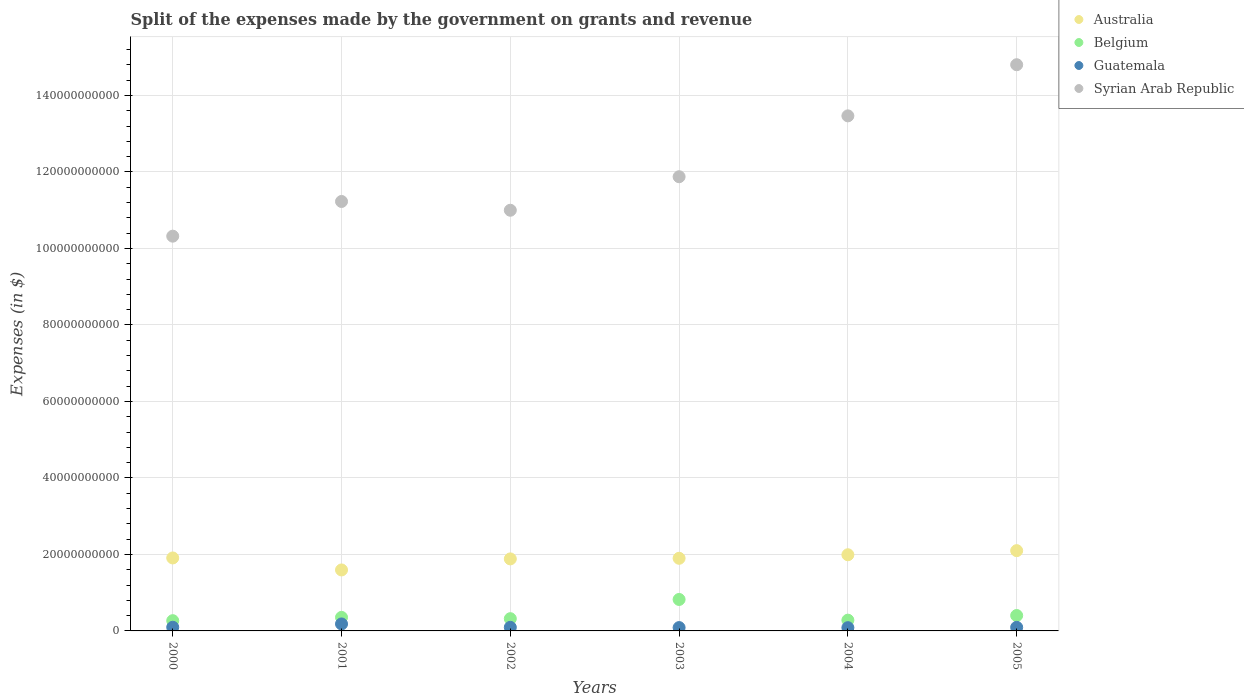Is the number of dotlines equal to the number of legend labels?
Ensure brevity in your answer.  Yes. What is the expenses made by the government on grants and revenue in Syrian Arab Republic in 2002?
Offer a terse response. 1.10e+11. Across all years, what is the maximum expenses made by the government on grants and revenue in Belgium?
Offer a very short reply. 8.23e+09. Across all years, what is the minimum expenses made by the government on grants and revenue in Guatemala?
Offer a very short reply. 8.48e+08. In which year was the expenses made by the government on grants and revenue in Australia maximum?
Your answer should be very brief. 2005. What is the total expenses made by the government on grants and revenue in Syrian Arab Republic in the graph?
Your answer should be compact. 7.27e+11. What is the difference between the expenses made by the government on grants and revenue in Australia in 2000 and that in 2001?
Give a very brief answer. 3.14e+09. What is the difference between the expenses made by the government on grants and revenue in Guatemala in 2004 and the expenses made by the government on grants and revenue in Syrian Arab Republic in 2000?
Your answer should be compact. -1.02e+11. What is the average expenses made by the government on grants and revenue in Belgium per year?
Provide a succinct answer. 4.08e+09. In the year 2001, what is the difference between the expenses made by the government on grants and revenue in Australia and expenses made by the government on grants and revenue in Syrian Arab Republic?
Give a very brief answer. -9.63e+1. What is the ratio of the expenses made by the government on grants and revenue in Syrian Arab Republic in 2000 to that in 2003?
Offer a very short reply. 0.87. Is the expenses made by the government on grants and revenue in Australia in 2003 less than that in 2005?
Offer a terse response. Yes. Is the difference between the expenses made by the government on grants and revenue in Australia in 2000 and 2005 greater than the difference between the expenses made by the government on grants and revenue in Syrian Arab Republic in 2000 and 2005?
Offer a terse response. Yes. What is the difference between the highest and the second highest expenses made by the government on grants and revenue in Syrian Arab Republic?
Make the answer very short. 1.34e+1. What is the difference between the highest and the lowest expenses made by the government on grants and revenue in Syrian Arab Republic?
Offer a very short reply. 4.48e+1. Is the sum of the expenses made by the government on grants and revenue in Belgium in 2002 and 2005 greater than the maximum expenses made by the government on grants and revenue in Syrian Arab Republic across all years?
Your answer should be very brief. No. Are the values on the major ticks of Y-axis written in scientific E-notation?
Offer a very short reply. No. Does the graph contain grids?
Your answer should be very brief. Yes. Where does the legend appear in the graph?
Provide a succinct answer. Top right. How many legend labels are there?
Give a very brief answer. 4. What is the title of the graph?
Your response must be concise. Split of the expenses made by the government on grants and revenue. Does "Liberia" appear as one of the legend labels in the graph?
Offer a very short reply. No. What is the label or title of the Y-axis?
Your answer should be compact. Expenses (in $). What is the Expenses (in $) in Australia in 2000?
Your answer should be compact. 1.91e+1. What is the Expenses (in $) in Belgium in 2000?
Provide a short and direct response. 2.68e+09. What is the Expenses (in $) of Guatemala in 2000?
Provide a short and direct response. 9.60e+08. What is the Expenses (in $) in Syrian Arab Republic in 2000?
Your answer should be compact. 1.03e+11. What is the Expenses (in $) in Australia in 2001?
Provide a short and direct response. 1.59e+1. What is the Expenses (in $) in Belgium in 2001?
Offer a terse response. 3.54e+09. What is the Expenses (in $) in Guatemala in 2001?
Provide a short and direct response. 1.82e+09. What is the Expenses (in $) in Syrian Arab Republic in 2001?
Your answer should be very brief. 1.12e+11. What is the Expenses (in $) of Australia in 2002?
Your answer should be very brief. 1.88e+1. What is the Expenses (in $) in Belgium in 2002?
Your answer should be very brief. 3.20e+09. What is the Expenses (in $) of Guatemala in 2002?
Give a very brief answer. 9.40e+08. What is the Expenses (in $) of Syrian Arab Republic in 2002?
Your response must be concise. 1.10e+11. What is the Expenses (in $) in Australia in 2003?
Offer a very short reply. 1.90e+1. What is the Expenses (in $) of Belgium in 2003?
Offer a very short reply. 8.23e+09. What is the Expenses (in $) of Guatemala in 2003?
Provide a short and direct response. 8.72e+08. What is the Expenses (in $) in Syrian Arab Republic in 2003?
Your answer should be very brief. 1.19e+11. What is the Expenses (in $) in Australia in 2004?
Ensure brevity in your answer.  1.99e+1. What is the Expenses (in $) of Belgium in 2004?
Make the answer very short. 2.81e+09. What is the Expenses (in $) in Guatemala in 2004?
Ensure brevity in your answer.  8.48e+08. What is the Expenses (in $) of Syrian Arab Republic in 2004?
Ensure brevity in your answer.  1.35e+11. What is the Expenses (in $) in Australia in 2005?
Your answer should be compact. 2.10e+1. What is the Expenses (in $) in Belgium in 2005?
Your response must be concise. 4.03e+09. What is the Expenses (in $) in Guatemala in 2005?
Your response must be concise. 9.38e+08. What is the Expenses (in $) of Syrian Arab Republic in 2005?
Ensure brevity in your answer.  1.48e+11. Across all years, what is the maximum Expenses (in $) of Australia?
Ensure brevity in your answer.  2.10e+1. Across all years, what is the maximum Expenses (in $) in Belgium?
Keep it short and to the point. 8.23e+09. Across all years, what is the maximum Expenses (in $) of Guatemala?
Keep it short and to the point. 1.82e+09. Across all years, what is the maximum Expenses (in $) of Syrian Arab Republic?
Offer a very short reply. 1.48e+11. Across all years, what is the minimum Expenses (in $) in Australia?
Your response must be concise. 1.59e+1. Across all years, what is the minimum Expenses (in $) of Belgium?
Provide a succinct answer. 2.68e+09. Across all years, what is the minimum Expenses (in $) in Guatemala?
Offer a very short reply. 8.48e+08. Across all years, what is the minimum Expenses (in $) of Syrian Arab Republic?
Your answer should be very brief. 1.03e+11. What is the total Expenses (in $) in Australia in the graph?
Ensure brevity in your answer.  1.14e+11. What is the total Expenses (in $) in Belgium in the graph?
Provide a succinct answer. 2.45e+1. What is the total Expenses (in $) in Guatemala in the graph?
Keep it short and to the point. 6.38e+09. What is the total Expenses (in $) in Syrian Arab Republic in the graph?
Make the answer very short. 7.27e+11. What is the difference between the Expenses (in $) of Australia in 2000 and that in 2001?
Your answer should be very brief. 3.14e+09. What is the difference between the Expenses (in $) in Belgium in 2000 and that in 2001?
Ensure brevity in your answer.  -8.60e+08. What is the difference between the Expenses (in $) of Guatemala in 2000 and that in 2001?
Offer a very short reply. -8.65e+08. What is the difference between the Expenses (in $) in Syrian Arab Republic in 2000 and that in 2001?
Keep it short and to the point. -9.07e+09. What is the difference between the Expenses (in $) of Australia in 2000 and that in 2002?
Your response must be concise. 2.47e+08. What is the difference between the Expenses (in $) of Belgium in 2000 and that in 2002?
Provide a short and direct response. -5.22e+08. What is the difference between the Expenses (in $) of Guatemala in 2000 and that in 2002?
Offer a terse response. 1.94e+07. What is the difference between the Expenses (in $) of Syrian Arab Republic in 2000 and that in 2002?
Provide a succinct answer. -6.78e+09. What is the difference between the Expenses (in $) of Australia in 2000 and that in 2003?
Provide a short and direct response. 8.90e+07. What is the difference between the Expenses (in $) in Belgium in 2000 and that in 2003?
Provide a short and direct response. -5.55e+09. What is the difference between the Expenses (in $) of Guatemala in 2000 and that in 2003?
Offer a terse response. 8.76e+07. What is the difference between the Expenses (in $) of Syrian Arab Republic in 2000 and that in 2003?
Your answer should be very brief. -1.55e+1. What is the difference between the Expenses (in $) of Australia in 2000 and that in 2004?
Provide a succinct answer. -8.35e+08. What is the difference between the Expenses (in $) in Belgium in 2000 and that in 2004?
Offer a terse response. -1.35e+08. What is the difference between the Expenses (in $) of Guatemala in 2000 and that in 2004?
Offer a terse response. 1.11e+08. What is the difference between the Expenses (in $) in Syrian Arab Republic in 2000 and that in 2004?
Your response must be concise. -3.15e+1. What is the difference between the Expenses (in $) of Australia in 2000 and that in 2005?
Keep it short and to the point. -1.91e+09. What is the difference between the Expenses (in $) in Belgium in 2000 and that in 2005?
Your answer should be very brief. -1.35e+09. What is the difference between the Expenses (in $) in Guatemala in 2000 and that in 2005?
Your answer should be compact. 2.17e+07. What is the difference between the Expenses (in $) in Syrian Arab Republic in 2000 and that in 2005?
Give a very brief answer. -4.48e+1. What is the difference between the Expenses (in $) in Australia in 2001 and that in 2002?
Offer a very short reply. -2.89e+09. What is the difference between the Expenses (in $) of Belgium in 2001 and that in 2002?
Your response must be concise. 3.37e+08. What is the difference between the Expenses (in $) of Guatemala in 2001 and that in 2002?
Provide a short and direct response. 8.85e+08. What is the difference between the Expenses (in $) in Syrian Arab Republic in 2001 and that in 2002?
Your answer should be very brief. 2.29e+09. What is the difference between the Expenses (in $) of Australia in 2001 and that in 2003?
Your answer should be very brief. -3.05e+09. What is the difference between the Expenses (in $) in Belgium in 2001 and that in 2003?
Offer a terse response. -4.69e+09. What is the difference between the Expenses (in $) in Guatemala in 2001 and that in 2003?
Provide a succinct answer. 9.53e+08. What is the difference between the Expenses (in $) in Syrian Arab Republic in 2001 and that in 2003?
Provide a short and direct response. -6.47e+09. What is the difference between the Expenses (in $) of Australia in 2001 and that in 2004?
Make the answer very short. -3.97e+09. What is the difference between the Expenses (in $) of Belgium in 2001 and that in 2004?
Your answer should be compact. 7.25e+08. What is the difference between the Expenses (in $) in Guatemala in 2001 and that in 2004?
Keep it short and to the point. 9.76e+08. What is the difference between the Expenses (in $) in Syrian Arab Republic in 2001 and that in 2004?
Provide a short and direct response. -2.24e+1. What is the difference between the Expenses (in $) of Australia in 2001 and that in 2005?
Offer a very short reply. -5.04e+09. What is the difference between the Expenses (in $) in Belgium in 2001 and that in 2005?
Offer a terse response. -4.90e+08. What is the difference between the Expenses (in $) of Guatemala in 2001 and that in 2005?
Offer a very short reply. 8.87e+08. What is the difference between the Expenses (in $) in Syrian Arab Republic in 2001 and that in 2005?
Ensure brevity in your answer.  -3.58e+1. What is the difference between the Expenses (in $) in Australia in 2002 and that in 2003?
Give a very brief answer. -1.58e+08. What is the difference between the Expenses (in $) of Belgium in 2002 and that in 2003?
Make the answer very short. -5.02e+09. What is the difference between the Expenses (in $) of Guatemala in 2002 and that in 2003?
Your answer should be very brief. 6.82e+07. What is the difference between the Expenses (in $) in Syrian Arab Republic in 2002 and that in 2003?
Your response must be concise. -8.76e+09. What is the difference between the Expenses (in $) in Australia in 2002 and that in 2004?
Provide a succinct answer. -1.08e+09. What is the difference between the Expenses (in $) in Belgium in 2002 and that in 2004?
Offer a very short reply. 3.88e+08. What is the difference between the Expenses (in $) of Guatemala in 2002 and that in 2004?
Your answer should be very brief. 9.19e+07. What is the difference between the Expenses (in $) in Syrian Arab Republic in 2002 and that in 2004?
Keep it short and to the point. -2.47e+1. What is the difference between the Expenses (in $) in Australia in 2002 and that in 2005?
Your response must be concise. -2.16e+09. What is the difference between the Expenses (in $) in Belgium in 2002 and that in 2005?
Offer a terse response. -8.27e+08. What is the difference between the Expenses (in $) in Guatemala in 2002 and that in 2005?
Offer a very short reply. 2.33e+06. What is the difference between the Expenses (in $) of Syrian Arab Republic in 2002 and that in 2005?
Provide a succinct answer. -3.80e+1. What is the difference between the Expenses (in $) of Australia in 2003 and that in 2004?
Offer a very short reply. -9.24e+08. What is the difference between the Expenses (in $) of Belgium in 2003 and that in 2004?
Make the answer very short. 5.41e+09. What is the difference between the Expenses (in $) in Guatemala in 2003 and that in 2004?
Provide a short and direct response. 2.36e+07. What is the difference between the Expenses (in $) of Syrian Arab Republic in 2003 and that in 2004?
Ensure brevity in your answer.  -1.59e+1. What is the difference between the Expenses (in $) in Australia in 2003 and that in 2005?
Ensure brevity in your answer.  -2.00e+09. What is the difference between the Expenses (in $) of Belgium in 2003 and that in 2005?
Offer a very short reply. 4.20e+09. What is the difference between the Expenses (in $) in Guatemala in 2003 and that in 2005?
Your response must be concise. -6.59e+07. What is the difference between the Expenses (in $) in Syrian Arab Republic in 2003 and that in 2005?
Provide a succinct answer. -2.93e+1. What is the difference between the Expenses (in $) of Australia in 2004 and that in 2005?
Provide a short and direct response. -1.07e+09. What is the difference between the Expenses (in $) in Belgium in 2004 and that in 2005?
Keep it short and to the point. -1.21e+09. What is the difference between the Expenses (in $) of Guatemala in 2004 and that in 2005?
Your answer should be very brief. -8.95e+07. What is the difference between the Expenses (in $) in Syrian Arab Republic in 2004 and that in 2005?
Your response must be concise. -1.34e+1. What is the difference between the Expenses (in $) in Australia in 2000 and the Expenses (in $) in Belgium in 2001?
Offer a very short reply. 1.55e+1. What is the difference between the Expenses (in $) of Australia in 2000 and the Expenses (in $) of Guatemala in 2001?
Provide a short and direct response. 1.73e+1. What is the difference between the Expenses (in $) of Australia in 2000 and the Expenses (in $) of Syrian Arab Republic in 2001?
Offer a very short reply. -9.32e+1. What is the difference between the Expenses (in $) of Belgium in 2000 and the Expenses (in $) of Guatemala in 2001?
Provide a succinct answer. 8.53e+08. What is the difference between the Expenses (in $) in Belgium in 2000 and the Expenses (in $) in Syrian Arab Republic in 2001?
Offer a terse response. -1.10e+11. What is the difference between the Expenses (in $) of Guatemala in 2000 and the Expenses (in $) of Syrian Arab Republic in 2001?
Ensure brevity in your answer.  -1.11e+11. What is the difference between the Expenses (in $) in Australia in 2000 and the Expenses (in $) in Belgium in 2002?
Your answer should be compact. 1.59e+1. What is the difference between the Expenses (in $) in Australia in 2000 and the Expenses (in $) in Guatemala in 2002?
Keep it short and to the point. 1.81e+1. What is the difference between the Expenses (in $) in Australia in 2000 and the Expenses (in $) in Syrian Arab Republic in 2002?
Your response must be concise. -9.09e+1. What is the difference between the Expenses (in $) in Belgium in 2000 and the Expenses (in $) in Guatemala in 2002?
Offer a very short reply. 1.74e+09. What is the difference between the Expenses (in $) in Belgium in 2000 and the Expenses (in $) in Syrian Arab Republic in 2002?
Provide a succinct answer. -1.07e+11. What is the difference between the Expenses (in $) of Guatemala in 2000 and the Expenses (in $) of Syrian Arab Republic in 2002?
Offer a very short reply. -1.09e+11. What is the difference between the Expenses (in $) of Australia in 2000 and the Expenses (in $) of Belgium in 2003?
Your answer should be compact. 1.09e+1. What is the difference between the Expenses (in $) of Australia in 2000 and the Expenses (in $) of Guatemala in 2003?
Your answer should be compact. 1.82e+1. What is the difference between the Expenses (in $) in Australia in 2000 and the Expenses (in $) in Syrian Arab Republic in 2003?
Your answer should be compact. -9.97e+1. What is the difference between the Expenses (in $) of Belgium in 2000 and the Expenses (in $) of Guatemala in 2003?
Provide a short and direct response. 1.81e+09. What is the difference between the Expenses (in $) in Belgium in 2000 and the Expenses (in $) in Syrian Arab Republic in 2003?
Give a very brief answer. -1.16e+11. What is the difference between the Expenses (in $) in Guatemala in 2000 and the Expenses (in $) in Syrian Arab Republic in 2003?
Offer a very short reply. -1.18e+11. What is the difference between the Expenses (in $) of Australia in 2000 and the Expenses (in $) of Belgium in 2004?
Your response must be concise. 1.63e+1. What is the difference between the Expenses (in $) in Australia in 2000 and the Expenses (in $) in Guatemala in 2004?
Offer a terse response. 1.82e+1. What is the difference between the Expenses (in $) of Australia in 2000 and the Expenses (in $) of Syrian Arab Republic in 2004?
Keep it short and to the point. -1.16e+11. What is the difference between the Expenses (in $) of Belgium in 2000 and the Expenses (in $) of Guatemala in 2004?
Offer a terse response. 1.83e+09. What is the difference between the Expenses (in $) in Belgium in 2000 and the Expenses (in $) in Syrian Arab Republic in 2004?
Provide a succinct answer. -1.32e+11. What is the difference between the Expenses (in $) of Guatemala in 2000 and the Expenses (in $) of Syrian Arab Republic in 2004?
Your answer should be very brief. -1.34e+11. What is the difference between the Expenses (in $) of Australia in 2000 and the Expenses (in $) of Belgium in 2005?
Ensure brevity in your answer.  1.51e+1. What is the difference between the Expenses (in $) in Australia in 2000 and the Expenses (in $) in Guatemala in 2005?
Provide a short and direct response. 1.81e+1. What is the difference between the Expenses (in $) of Australia in 2000 and the Expenses (in $) of Syrian Arab Republic in 2005?
Keep it short and to the point. -1.29e+11. What is the difference between the Expenses (in $) in Belgium in 2000 and the Expenses (in $) in Guatemala in 2005?
Ensure brevity in your answer.  1.74e+09. What is the difference between the Expenses (in $) in Belgium in 2000 and the Expenses (in $) in Syrian Arab Republic in 2005?
Offer a very short reply. -1.45e+11. What is the difference between the Expenses (in $) in Guatemala in 2000 and the Expenses (in $) in Syrian Arab Republic in 2005?
Keep it short and to the point. -1.47e+11. What is the difference between the Expenses (in $) in Australia in 2001 and the Expenses (in $) in Belgium in 2002?
Make the answer very short. 1.27e+1. What is the difference between the Expenses (in $) in Australia in 2001 and the Expenses (in $) in Guatemala in 2002?
Your answer should be compact. 1.50e+1. What is the difference between the Expenses (in $) in Australia in 2001 and the Expenses (in $) in Syrian Arab Republic in 2002?
Provide a succinct answer. -9.40e+1. What is the difference between the Expenses (in $) of Belgium in 2001 and the Expenses (in $) of Guatemala in 2002?
Provide a short and direct response. 2.60e+09. What is the difference between the Expenses (in $) in Belgium in 2001 and the Expenses (in $) in Syrian Arab Republic in 2002?
Ensure brevity in your answer.  -1.06e+11. What is the difference between the Expenses (in $) of Guatemala in 2001 and the Expenses (in $) of Syrian Arab Republic in 2002?
Your response must be concise. -1.08e+11. What is the difference between the Expenses (in $) in Australia in 2001 and the Expenses (in $) in Belgium in 2003?
Offer a terse response. 7.72e+09. What is the difference between the Expenses (in $) of Australia in 2001 and the Expenses (in $) of Guatemala in 2003?
Ensure brevity in your answer.  1.51e+1. What is the difference between the Expenses (in $) of Australia in 2001 and the Expenses (in $) of Syrian Arab Republic in 2003?
Offer a terse response. -1.03e+11. What is the difference between the Expenses (in $) of Belgium in 2001 and the Expenses (in $) of Guatemala in 2003?
Make the answer very short. 2.67e+09. What is the difference between the Expenses (in $) of Belgium in 2001 and the Expenses (in $) of Syrian Arab Republic in 2003?
Your answer should be very brief. -1.15e+11. What is the difference between the Expenses (in $) in Guatemala in 2001 and the Expenses (in $) in Syrian Arab Republic in 2003?
Offer a terse response. -1.17e+11. What is the difference between the Expenses (in $) of Australia in 2001 and the Expenses (in $) of Belgium in 2004?
Your response must be concise. 1.31e+1. What is the difference between the Expenses (in $) of Australia in 2001 and the Expenses (in $) of Guatemala in 2004?
Make the answer very short. 1.51e+1. What is the difference between the Expenses (in $) of Australia in 2001 and the Expenses (in $) of Syrian Arab Republic in 2004?
Provide a succinct answer. -1.19e+11. What is the difference between the Expenses (in $) of Belgium in 2001 and the Expenses (in $) of Guatemala in 2004?
Provide a succinct answer. 2.69e+09. What is the difference between the Expenses (in $) of Belgium in 2001 and the Expenses (in $) of Syrian Arab Republic in 2004?
Provide a short and direct response. -1.31e+11. What is the difference between the Expenses (in $) of Guatemala in 2001 and the Expenses (in $) of Syrian Arab Republic in 2004?
Provide a succinct answer. -1.33e+11. What is the difference between the Expenses (in $) in Australia in 2001 and the Expenses (in $) in Belgium in 2005?
Provide a short and direct response. 1.19e+1. What is the difference between the Expenses (in $) of Australia in 2001 and the Expenses (in $) of Guatemala in 2005?
Your answer should be very brief. 1.50e+1. What is the difference between the Expenses (in $) in Australia in 2001 and the Expenses (in $) in Syrian Arab Republic in 2005?
Your answer should be compact. -1.32e+11. What is the difference between the Expenses (in $) of Belgium in 2001 and the Expenses (in $) of Guatemala in 2005?
Make the answer very short. 2.60e+09. What is the difference between the Expenses (in $) of Belgium in 2001 and the Expenses (in $) of Syrian Arab Republic in 2005?
Offer a very short reply. -1.44e+11. What is the difference between the Expenses (in $) of Guatemala in 2001 and the Expenses (in $) of Syrian Arab Republic in 2005?
Offer a terse response. -1.46e+11. What is the difference between the Expenses (in $) in Australia in 2002 and the Expenses (in $) in Belgium in 2003?
Offer a very short reply. 1.06e+1. What is the difference between the Expenses (in $) of Australia in 2002 and the Expenses (in $) of Guatemala in 2003?
Provide a succinct answer. 1.80e+1. What is the difference between the Expenses (in $) in Australia in 2002 and the Expenses (in $) in Syrian Arab Republic in 2003?
Your answer should be very brief. -9.99e+1. What is the difference between the Expenses (in $) in Belgium in 2002 and the Expenses (in $) in Guatemala in 2003?
Give a very brief answer. 2.33e+09. What is the difference between the Expenses (in $) of Belgium in 2002 and the Expenses (in $) of Syrian Arab Republic in 2003?
Give a very brief answer. -1.16e+11. What is the difference between the Expenses (in $) of Guatemala in 2002 and the Expenses (in $) of Syrian Arab Republic in 2003?
Make the answer very short. -1.18e+11. What is the difference between the Expenses (in $) in Australia in 2002 and the Expenses (in $) in Belgium in 2004?
Keep it short and to the point. 1.60e+1. What is the difference between the Expenses (in $) of Australia in 2002 and the Expenses (in $) of Guatemala in 2004?
Your response must be concise. 1.80e+1. What is the difference between the Expenses (in $) in Australia in 2002 and the Expenses (in $) in Syrian Arab Republic in 2004?
Your response must be concise. -1.16e+11. What is the difference between the Expenses (in $) in Belgium in 2002 and the Expenses (in $) in Guatemala in 2004?
Offer a very short reply. 2.35e+09. What is the difference between the Expenses (in $) in Belgium in 2002 and the Expenses (in $) in Syrian Arab Republic in 2004?
Give a very brief answer. -1.31e+11. What is the difference between the Expenses (in $) of Guatemala in 2002 and the Expenses (in $) of Syrian Arab Republic in 2004?
Make the answer very short. -1.34e+11. What is the difference between the Expenses (in $) of Australia in 2002 and the Expenses (in $) of Belgium in 2005?
Offer a terse response. 1.48e+1. What is the difference between the Expenses (in $) in Australia in 2002 and the Expenses (in $) in Guatemala in 2005?
Make the answer very short. 1.79e+1. What is the difference between the Expenses (in $) in Australia in 2002 and the Expenses (in $) in Syrian Arab Republic in 2005?
Offer a very short reply. -1.29e+11. What is the difference between the Expenses (in $) in Belgium in 2002 and the Expenses (in $) in Guatemala in 2005?
Your answer should be very brief. 2.26e+09. What is the difference between the Expenses (in $) of Belgium in 2002 and the Expenses (in $) of Syrian Arab Republic in 2005?
Keep it short and to the point. -1.45e+11. What is the difference between the Expenses (in $) in Guatemala in 2002 and the Expenses (in $) in Syrian Arab Republic in 2005?
Your answer should be compact. -1.47e+11. What is the difference between the Expenses (in $) in Australia in 2003 and the Expenses (in $) in Belgium in 2004?
Offer a terse response. 1.62e+1. What is the difference between the Expenses (in $) of Australia in 2003 and the Expenses (in $) of Guatemala in 2004?
Make the answer very short. 1.81e+1. What is the difference between the Expenses (in $) of Australia in 2003 and the Expenses (in $) of Syrian Arab Republic in 2004?
Provide a succinct answer. -1.16e+11. What is the difference between the Expenses (in $) in Belgium in 2003 and the Expenses (in $) in Guatemala in 2004?
Your answer should be very brief. 7.38e+09. What is the difference between the Expenses (in $) in Belgium in 2003 and the Expenses (in $) in Syrian Arab Republic in 2004?
Offer a terse response. -1.26e+11. What is the difference between the Expenses (in $) of Guatemala in 2003 and the Expenses (in $) of Syrian Arab Republic in 2004?
Your answer should be very brief. -1.34e+11. What is the difference between the Expenses (in $) of Australia in 2003 and the Expenses (in $) of Belgium in 2005?
Your answer should be very brief. 1.50e+1. What is the difference between the Expenses (in $) of Australia in 2003 and the Expenses (in $) of Guatemala in 2005?
Offer a very short reply. 1.81e+1. What is the difference between the Expenses (in $) in Australia in 2003 and the Expenses (in $) in Syrian Arab Republic in 2005?
Keep it short and to the point. -1.29e+11. What is the difference between the Expenses (in $) of Belgium in 2003 and the Expenses (in $) of Guatemala in 2005?
Provide a succinct answer. 7.29e+09. What is the difference between the Expenses (in $) in Belgium in 2003 and the Expenses (in $) in Syrian Arab Republic in 2005?
Offer a very short reply. -1.40e+11. What is the difference between the Expenses (in $) of Guatemala in 2003 and the Expenses (in $) of Syrian Arab Republic in 2005?
Make the answer very short. -1.47e+11. What is the difference between the Expenses (in $) of Australia in 2004 and the Expenses (in $) of Belgium in 2005?
Your answer should be compact. 1.59e+1. What is the difference between the Expenses (in $) in Australia in 2004 and the Expenses (in $) in Guatemala in 2005?
Ensure brevity in your answer.  1.90e+1. What is the difference between the Expenses (in $) of Australia in 2004 and the Expenses (in $) of Syrian Arab Republic in 2005?
Your answer should be compact. -1.28e+11. What is the difference between the Expenses (in $) of Belgium in 2004 and the Expenses (in $) of Guatemala in 2005?
Your response must be concise. 1.87e+09. What is the difference between the Expenses (in $) of Belgium in 2004 and the Expenses (in $) of Syrian Arab Republic in 2005?
Provide a succinct answer. -1.45e+11. What is the difference between the Expenses (in $) in Guatemala in 2004 and the Expenses (in $) in Syrian Arab Republic in 2005?
Offer a very short reply. -1.47e+11. What is the average Expenses (in $) in Australia per year?
Provide a short and direct response. 1.90e+1. What is the average Expenses (in $) of Belgium per year?
Your answer should be compact. 4.08e+09. What is the average Expenses (in $) of Guatemala per year?
Offer a terse response. 1.06e+09. What is the average Expenses (in $) of Syrian Arab Republic per year?
Make the answer very short. 1.21e+11. In the year 2000, what is the difference between the Expenses (in $) in Australia and Expenses (in $) in Belgium?
Your answer should be very brief. 1.64e+1. In the year 2000, what is the difference between the Expenses (in $) in Australia and Expenses (in $) in Guatemala?
Your answer should be compact. 1.81e+1. In the year 2000, what is the difference between the Expenses (in $) in Australia and Expenses (in $) in Syrian Arab Republic?
Ensure brevity in your answer.  -8.41e+1. In the year 2000, what is the difference between the Expenses (in $) of Belgium and Expenses (in $) of Guatemala?
Offer a very short reply. 1.72e+09. In the year 2000, what is the difference between the Expenses (in $) of Belgium and Expenses (in $) of Syrian Arab Republic?
Your answer should be very brief. -1.01e+11. In the year 2000, what is the difference between the Expenses (in $) in Guatemala and Expenses (in $) in Syrian Arab Republic?
Ensure brevity in your answer.  -1.02e+11. In the year 2001, what is the difference between the Expenses (in $) in Australia and Expenses (in $) in Belgium?
Provide a succinct answer. 1.24e+1. In the year 2001, what is the difference between the Expenses (in $) of Australia and Expenses (in $) of Guatemala?
Provide a succinct answer. 1.41e+1. In the year 2001, what is the difference between the Expenses (in $) of Australia and Expenses (in $) of Syrian Arab Republic?
Ensure brevity in your answer.  -9.63e+1. In the year 2001, what is the difference between the Expenses (in $) of Belgium and Expenses (in $) of Guatemala?
Give a very brief answer. 1.71e+09. In the year 2001, what is the difference between the Expenses (in $) in Belgium and Expenses (in $) in Syrian Arab Republic?
Your answer should be compact. -1.09e+11. In the year 2001, what is the difference between the Expenses (in $) in Guatemala and Expenses (in $) in Syrian Arab Republic?
Provide a short and direct response. -1.10e+11. In the year 2002, what is the difference between the Expenses (in $) of Australia and Expenses (in $) of Belgium?
Provide a short and direct response. 1.56e+1. In the year 2002, what is the difference between the Expenses (in $) of Australia and Expenses (in $) of Guatemala?
Provide a short and direct response. 1.79e+1. In the year 2002, what is the difference between the Expenses (in $) of Australia and Expenses (in $) of Syrian Arab Republic?
Make the answer very short. -9.12e+1. In the year 2002, what is the difference between the Expenses (in $) in Belgium and Expenses (in $) in Guatemala?
Give a very brief answer. 2.26e+09. In the year 2002, what is the difference between the Expenses (in $) of Belgium and Expenses (in $) of Syrian Arab Republic?
Keep it short and to the point. -1.07e+11. In the year 2002, what is the difference between the Expenses (in $) in Guatemala and Expenses (in $) in Syrian Arab Republic?
Offer a very short reply. -1.09e+11. In the year 2003, what is the difference between the Expenses (in $) of Australia and Expenses (in $) of Belgium?
Give a very brief answer. 1.08e+1. In the year 2003, what is the difference between the Expenses (in $) of Australia and Expenses (in $) of Guatemala?
Offer a very short reply. 1.81e+1. In the year 2003, what is the difference between the Expenses (in $) in Australia and Expenses (in $) in Syrian Arab Republic?
Provide a succinct answer. -9.98e+1. In the year 2003, what is the difference between the Expenses (in $) of Belgium and Expenses (in $) of Guatemala?
Your answer should be very brief. 7.35e+09. In the year 2003, what is the difference between the Expenses (in $) of Belgium and Expenses (in $) of Syrian Arab Republic?
Offer a terse response. -1.11e+11. In the year 2003, what is the difference between the Expenses (in $) of Guatemala and Expenses (in $) of Syrian Arab Republic?
Offer a very short reply. -1.18e+11. In the year 2004, what is the difference between the Expenses (in $) in Australia and Expenses (in $) in Belgium?
Provide a succinct answer. 1.71e+1. In the year 2004, what is the difference between the Expenses (in $) of Australia and Expenses (in $) of Guatemala?
Give a very brief answer. 1.91e+1. In the year 2004, what is the difference between the Expenses (in $) in Australia and Expenses (in $) in Syrian Arab Republic?
Your answer should be compact. -1.15e+11. In the year 2004, what is the difference between the Expenses (in $) of Belgium and Expenses (in $) of Guatemala?
Ensure brevity in your answer.  1.96e+09. In the year 2004, what is the difference between the Expenses (in $) in Belgium and Expenses (in $) in Syrian Arab Republic?
Provide a short and direct response. -1.32e+11. In the year 2004, what is the difference between the Expenses (in $) in Guatemala and Expenses (in $) in Syrian Arab Republic?
Offer a terse response. -1.34e+11. In the year 2005, what is the difference between the Expenses (in $) of Australia and Expenses (in $) of Belgium?
Provide a short and direct response. 1.70e+1. In the year 2005, what is the difference between the Expenses (in $) in Australia and Expenses (in $) in Guatemala?
Keep it short and to the point. 2.00e+1. In the year 2005, what is the difference between the Expenses (in $) of Australia and Expenses (in $) of Syrian Arab Republic?
Provide a succinct answer. -1.27e+11. In the year 2005, what is the difference between the Expenses (in $) of Belgium and Expenses (in $) of Guatemala?
Your answer should be compact. 3.09e+09. In the year 2005, what is the difference between the Expenses (in $) in Belgium and Expenses (in $) in Syrian Arab Republic?
Ensure brevity in your answer.  -1.44e+11. In the year 2005, what is the difference between the Expenses (in $) of Guatemala and Expenses (in $) of Syrian Arab Republic?
Ensure brevity in your answer.  -1.47e+11. What is the ratio of the Expenses (in $) of Australia in 2000 to that in 2001?
Your answer should be very brief. 1.2. What is the ratio of the Expenses (in $) of Belgium in 2000 to that in 2001?
Your answer should be very brief. 0.76. What is the ratio of the Expenses (in $) in Guatemala in 2000 to that in 2001?
Offer a terse response. 0.53. What is the ratio of the Expenses (in $) of Syrian Arab Republic in 2000 to that in 2001?
Provide a short and direct response. 0.92. What is the ratio of the Expenses (in $) of Australia in 2000 to that in 2002?
Offer a terse response. 1.01. What is the ratio of the Expenses (in $) in Belgium in 2000 to that in 2002?
Keep it short and to the point. 0.84. What is the ratio of the Expenses (in $) of Guatemala in 2000 to that in 2002?
Offer a very short reply. 1.02. What is the ratio of the Expenses (in $) of Syrian Arab Republic in 2000 to that in 2002?
Make the answer very short. 0.94. What is the ratio of the Expenses (in $) in Australia in 2000 to that in 2003?
Keep it short and to the point. 1. What is the ratio of the Expenses (in $) of Belgium in 2000 to that in 2003?
Make the answer very short. 0.33. What is the ratio of the Expenses (in $) in Guatemala in 2000 to that in 2003?
Offer a terse response. 1.1. What is the ratio of the Expenses (in $) in Syrian Arab Republic in 2000 to that in 2003?
Provide a short and direct response. 0.87. What is the ratio of the Expenses (in $) in Australia in 2000 to that in 2004?
Your response must be concise. 0.96. What is the ratio of the Expenses (in $) of Belgium in 2000 to that in 2004?
Your response must be concise. 0.95. What is the ratio of the Expenses (in $) in Guatemala in 2000 to that in 2004?
Give a very brief answer. 1.13. What is the ratio of the Expenses (in $) of Syrian Arab Republic in 2000 to that in 2004?
Your answer should be very brief. 0.77. What is the ratio of the Expenses (in $) of Australia in 2000 to that in 2005?
Your answer should be compact. 0.91. What is the ratio of the Expenses (in $) of Belgium in 2000 to that in 2005?
Provide a succinct answer. 0.67. What is the ratio of the Expenses (in $) in Guatemala in 2000 to that in 2005?
Your answer should be compact. 1.02. What is the ratio of the Expenses (in $) in Syrian Arab Republic in 2000 to that in 2005?
Offer a terse response. 0.7. What is the ratio of the Expenses (in $) in Australia in 2001 to that in 2002?
Make the answer very short. 0.85. What is the ratio of the Expenses (in $) of Belgium in 2001 to that in 2002?
Give a very brief answer. 1.11. What is the ratio of the Expenses (in $) of Guatemala in 2001 to that in 2002?
Offer a very short reply. 1.94. What is the ratio of the Expenses (in $) of Syrian Arab Republic in 2001 to that in 2002?
Provide a short and direct response. 1.02. What is the ratio of the Expenses (in $) in Australia in 2001 to that in 2003?
Make the answer very short. 0.84. What is the ratio of the Expenses (in $) in Belgium in 2001 to that in 2003?
Provide a short and direct response. 0.43. What is the ratio of the Expenses (in $) of Guatemala in 2001 to that in 2003?
Give a very brief answer. 2.09. What is the ratio of the Expenses (in $) in Syrian Arab Republic in 2001 to that in 2003?
Your answer should be very brief. 0.95. What is the ratio of the Expenses (in $) of Australia in 2001 to that in 2004?
Ensure brevity in your answer.  0.8. What is the ratio of the Expenses (in $) in Belgium in 2001 to that in 2004?
Your answer should be compact. 1.26. What is the ratio of the Expenses (in $) of Guatemala in 2001 to that in 2004?
Provide a succinct answer. 2.15. What is the ratio of the Expenses (in $) of Syrian Arab Republic in 2001 to that in 2004?
Make the answer very short. 0.83. What is the ratio of the Expenses (in $) in Australia in 2001 to that in 2005?
Your answer should be very brief. 0.76. What is the ratio of the Expenses (in $) in Belgium in 2001 to that in 2005?
Provide a short and direct response. 0.88. What is the ratio of the Expenses (in $) of Guatemala in 2001 to that in 2005?
Your answer should be compact. 1.95. What is the ratio of the Expenses (in $) in Syrian Arab Republic in 2001 to that in 2005?
Ensure brevity in your answer.  0.76. What is the ratio of the Expenses (in $) in Belgium in 2002 to that in 2003?
Ensure brevity in your answer.  0.39. What is the ratio of the Expenses (in $) in Guatemala in 2002 to that in 2003?
Make the answer very short. 1.08. What is the ratio of the Expenses (in $) in Syrian Arab Republic in 2002 to that in 2003?
Ensure brevity in your answer.  0.93. What is the ratio of the Expenses (in $) in Australia in 2002 to that in 2004?
Provide a short and direct response. 0.95. What is the ratio of the Expenses (in $) of Belgium in 2002 to that in 2004?
Provide a succinct answer. 1.14. What is the ratio of the Expenses (in $) in Guatemala in 2002 to that in 2004?
Keep it short and to the point. 1.11. What is the ratio of the Expenses (in $) of Syrian Arab Republic in 2002 to that in 2004?
Provide a short and direct response. 0.82. What is the ratio of the Expenses (in $) in Australia in 2002 to that in 2005?
Provide a short and direct response. 0.9. What is the ratio of the Expenses (in $) in Belgium in 2002 to that in 2005?
Give a very brief answer. 0.79. What is the ratio of the Expenses (in $) of Syrian Arab Republic in 2002 to that in 2005?
Ensure brevity in your answer.  0.74. What is the ratio of the Expenses (in $) of Australia in 2003 to that in 2004?
Keep it short and to the point. 0.95. What is the ratio of the Expenses (in $) in Belgium in 2003 to that in 2004?
Provide a short and direct response. 2.92. What is the ratio of the Expenses (in $) of Guatemala in 2003 to that in 2004?
Your response must be concise. 1.03. What is the ratio of the Expenses (in $) in Syrian Arab Republic in 2003 to that in 2004?
Give a very brief answer. 0.88. What is the ratio of the Expenses (in $) in Australia in 2003 to that in 2005?
Your response must be concise. 0.9. What is the ratio of the Expenses (in $) in Belgium in 2003 to that in 2005?
Ensure brevity in your answer.  2.04. What is the ratio of the Expenses (in $) in Guatemala in 2003 to that in 2005?
Give a very brief answer. 0.93. What is the ratio of the Expenses (in $) in Syrian Arab Republic in 2003 to that in 2005?
Provide a succinct answer. 0.8. What is the ratio of the Expenses (in $) of Australia in 2004 to that in 2005?
Provide a short and direct response. 0.95. What is the ratio of the Expenses (in $) in Belgium in 2004 to that in 2005?
Your answer should be compact. 0.7. What is the ratio of the Expenses (in $) in Guatemala in 2004 to that in 2005?
Keep it short and to the point. 0.9. What is the ratio of the Expenses (in $) of Syrian Arab Republic in 2004 to that in 2005?
Make the answer very short. 0.91. What is the difference between the highest and the second highest Expenses (in $) of Australia?
Offer a terse response. 1.07e+09. What is the difference between the highest and the second highest Expenses (in $) in Belgium?
Make the answer very short. 4.20e+09. What is the difference between the highest and the second highest Expenses (in $) of Guatemala?
Provide a short and direct response. 8.65e+08. What is the difference between the highest and the second highest Expenses (in $) in Syrian Arab Republic?
Ensure brevity in your answer.  1.34e+1. What is the difference between the highest and the lowest Expenses (in $) in Australia?
Keep it short and to the point. 5.04e+09. What is the difference between the highest and the lowest Expenses (in $) of Belgium?
Offer a very short reply. 5.55e+09. What is the difference between the highest and the lowest Expenses (in $) of Guatemala?
Your answer should be very brief. 9.76e+08. What is the difference between the highest and the lowest Expenses (in $) of Syrian Arab Republic?
Offer a very short reply. 4.48e+1. 